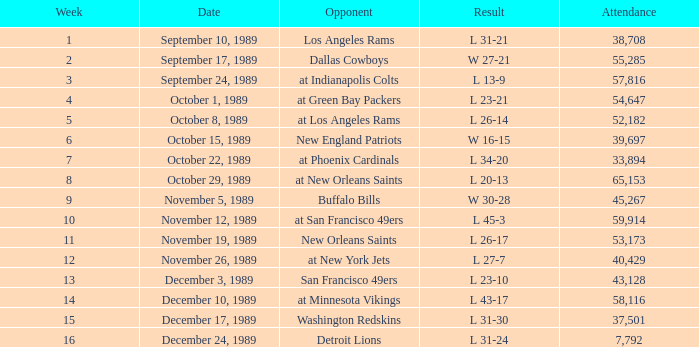On september 10, 1989, how many individuals were present at the match? 38708.0. 